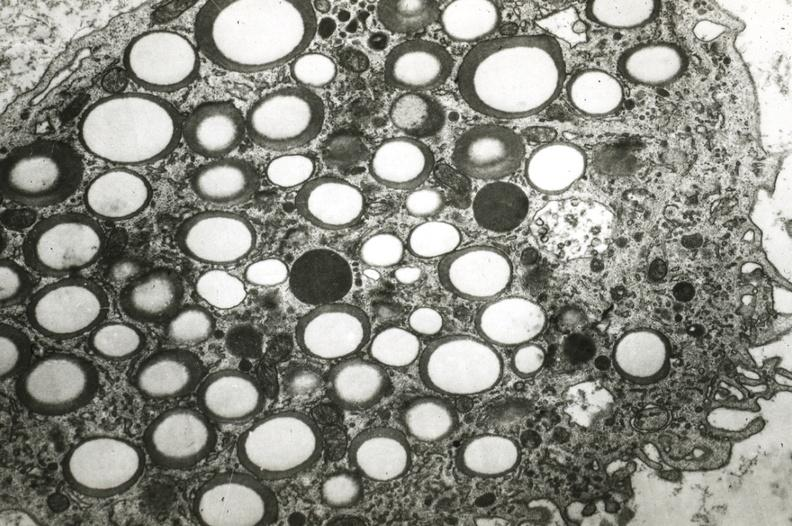s vasculature present?
Answer the question using a single word or phrase. Yes 